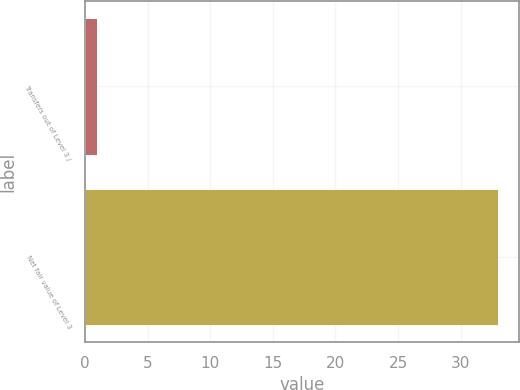<chart> <loc_0><loc_0><loc_500><loc_500><bar_chart><fcel>Transfers out of Level 3 /<fcel>Net fair value of Level 3<nl><fcel>1<fcel>33<nl></chart> 